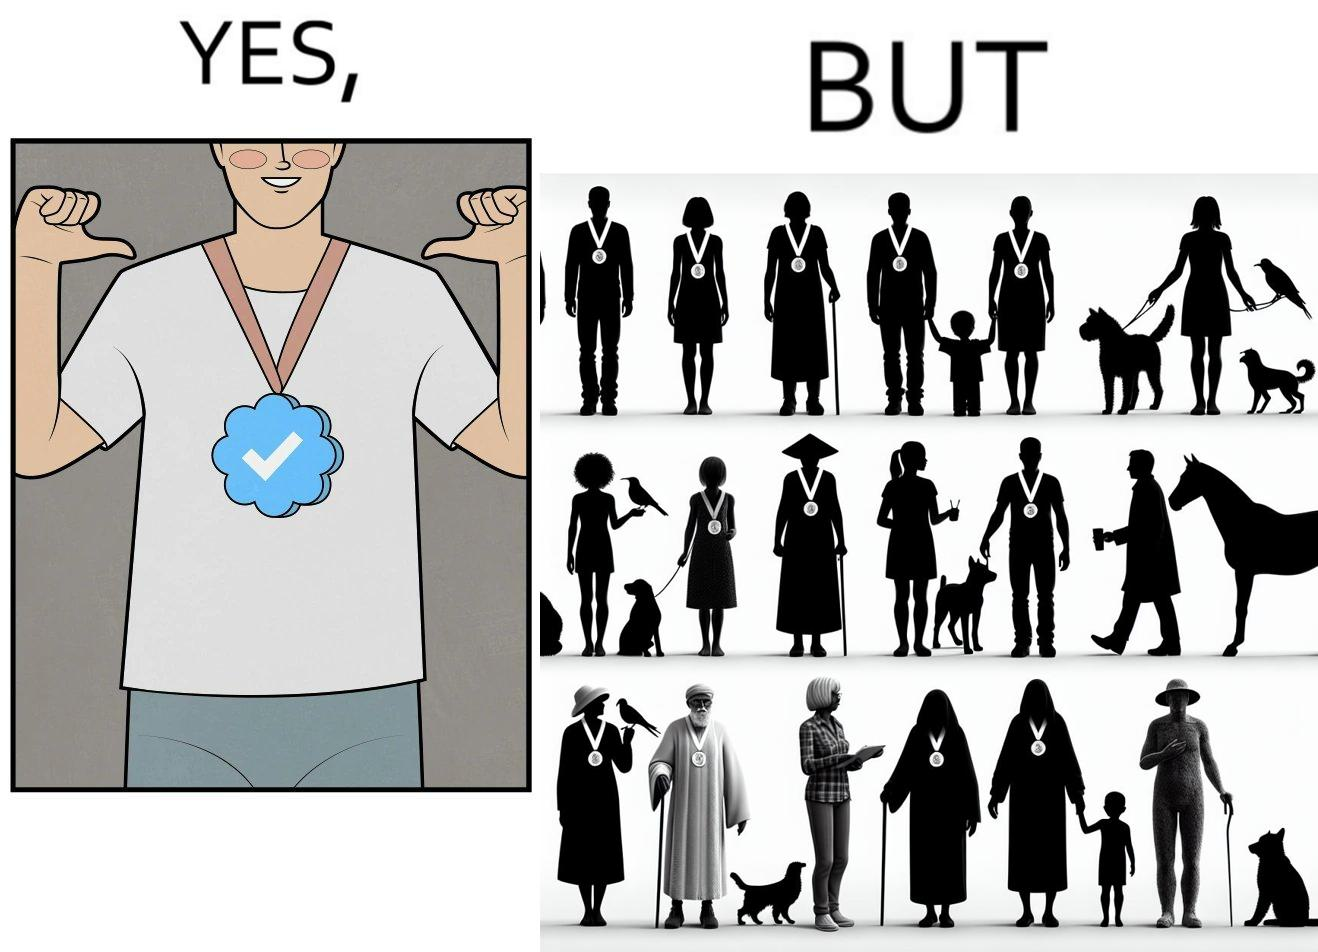Provide a description of this image. The images are funny since they show a man who thinks he has made a great achievement by winning a medal and is proud while everyone around him has the same medal and have achieved the same thing as he has 